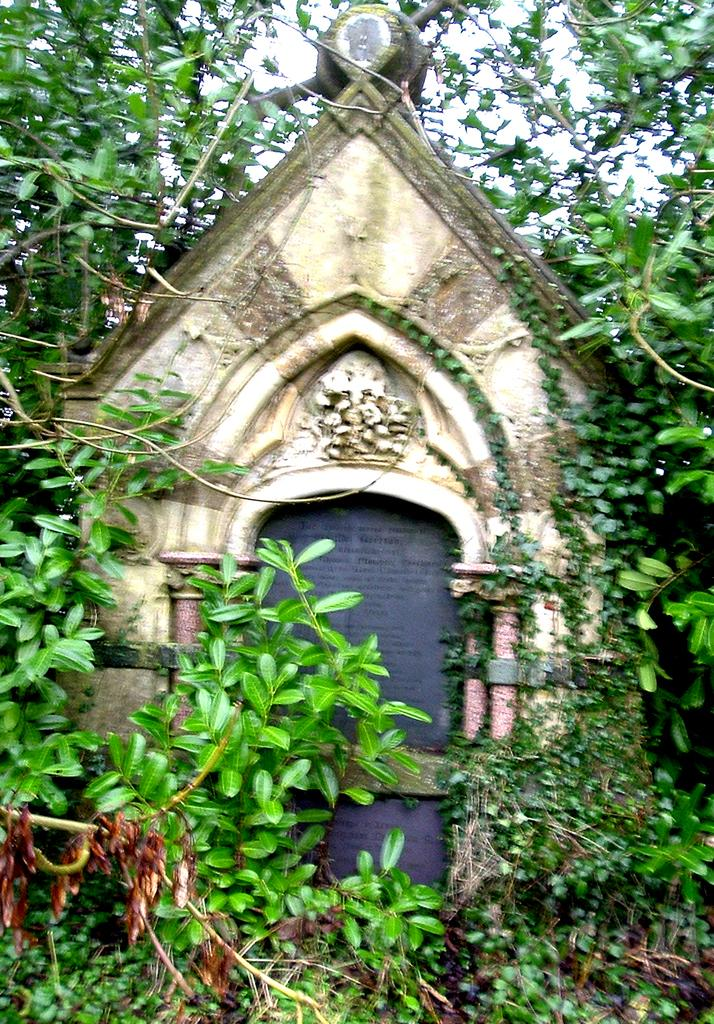What structure is present in the image? There is an arch in the image. What is surrounding the arch? There are plants around the arch. What can be seen in the background of the image? There are trees in the background of the image. How would you describe the sky in the image? The sky is clear in the image. How does the wave interact with the arch in the image? There is no wave present in the image, so it cannot interact with the arch. 